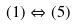<formula> <loc_0><loc_0><loc_500><loc_500>( 1 ) \Leftrightarrow ( 5 )</formula> 